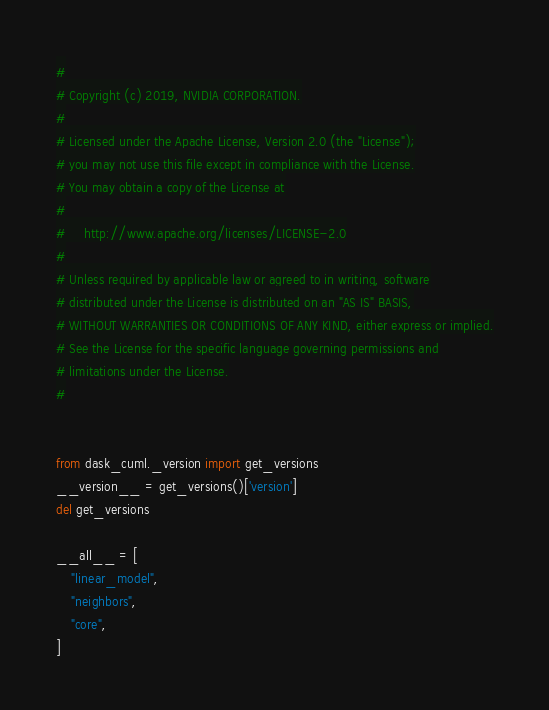<code> <loc_0><loc_0><loc_500><loc_500><_Python_>#
# Copyright (c) 2019, NVIDIA CORPORATION.
#
# Licensed under the Apache License, Version 2.0 (the "License");
# you may not use this file except in compliance with the License.
# You may obtain a copy of the License at
#
#     http://www.apache.org/licenses/LICENSE-2.0
#
# Unless required by applicable law or agreed to in writing, software
# distributed under the License is distributed on an "AS IS" BASIS,
# WITHOUT WARRANTIES OR CONDITIONS OF ANY KIND, either express or implied.
# See the License for the specific language governing permissions and
# limitations under the License.
#


from dask_cuml._version import get_versions
__version__ = get_versions()['version']
del get_versions

__all__ = [
    "linear_model",
    "neighbors",
    "core",
]
</code> 